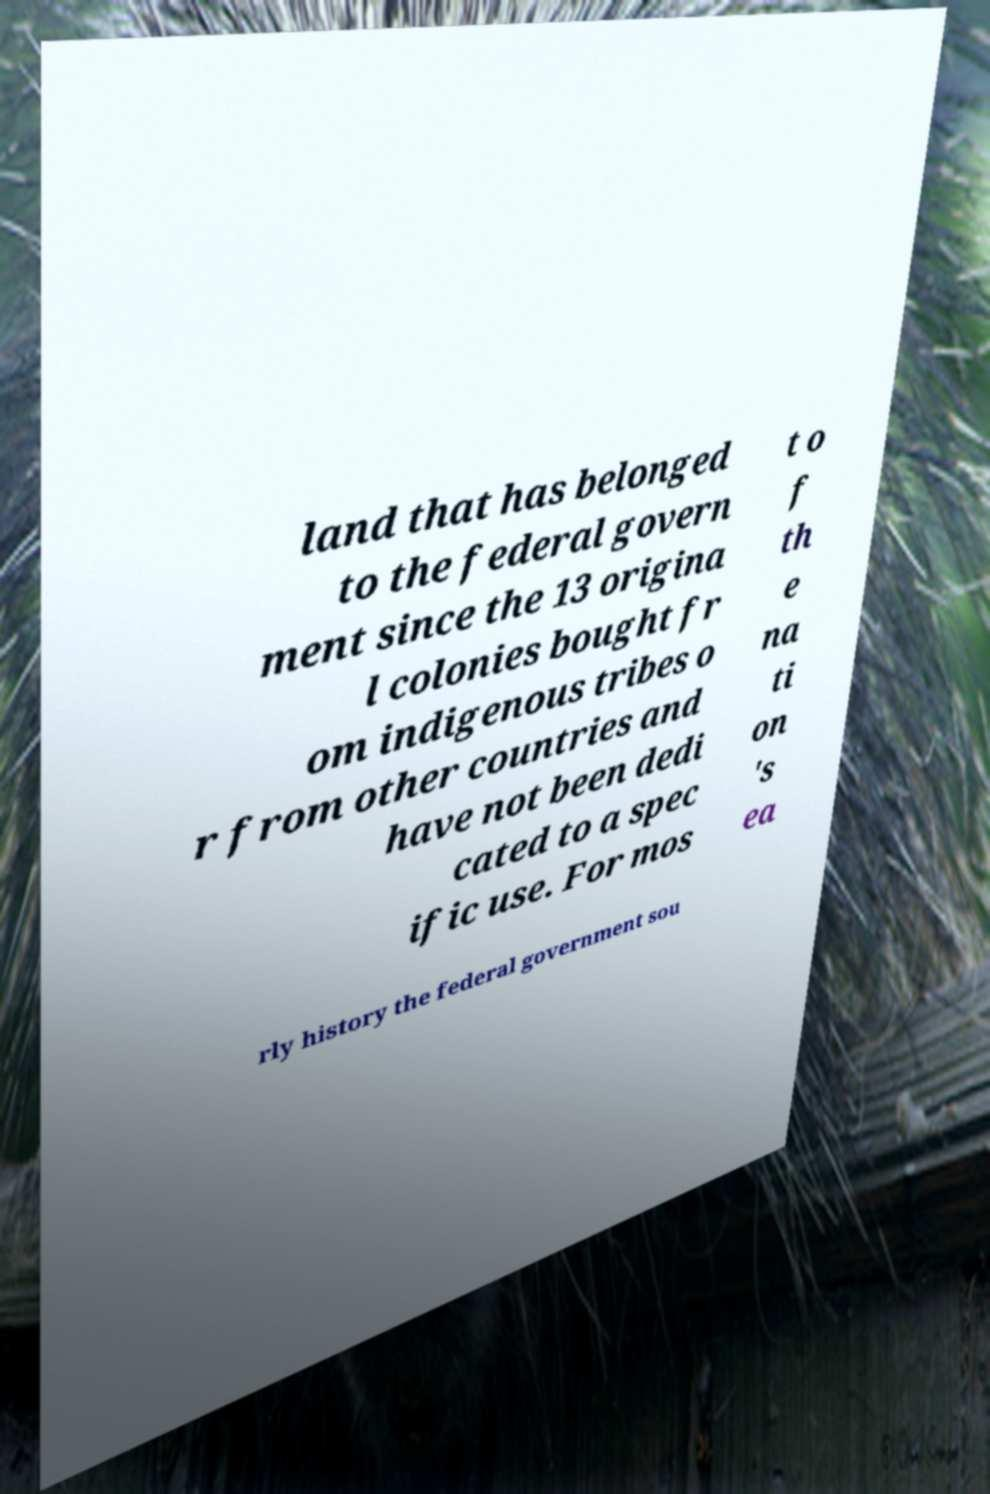There's text embedded in this image that I need extracted. Can you transcribe it verbatim? land that has belonged to the federal govern ment since the 13 origina l colonies bought fr om indigenous tribes o r from other countries and have not been dedi cated to a spec ific use. For mos t o f th e na ti on 's ea rly history the federal government sou 